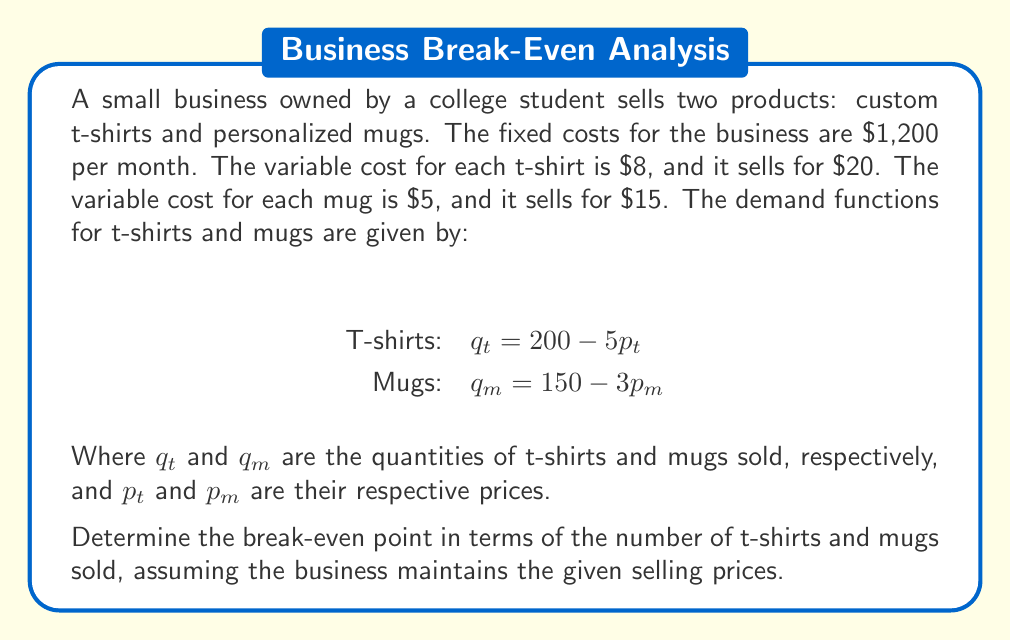Can you solve this math problem? Let's approach this step-by-step:

1) First, we need to express the quantities in terms of the given prices:
   T-shirts: $q_t = 200 - 5(20) = 100$
   Mugs: $q_m = 150 - 3(15) = 105$

2) Now, let's define our variables:
   Let x be the number of t-shirts sold
   Let y be the number of mugs sold

3) We can now set up our break-even equation:
   Revenue = Total Costs
   $20x + 15y = 1200 + 8x + 5y$

4) Simplify the equation:
   $12x + 10y = 1200$

5) We need a second equation to solve this system. We can use the ratio of the maximum quantities sold:
   $\frac{x}{y} = \frac{100}{105}$

6) Simplify this ratio:
   $21x = 20y$

7) Now we have a system of two equations:
   $12x + 10y = 1200$
   $21x - 20y = 0$

8) Multiply the second equation by 10:
   $12x + 10y = 1200$
   $210x - 200y = 0$

9) Add these equations:
   $222x - 190y = 1200$

10) Substitute $y = \frac{21x}{20}$ from step 6 into this equation:
    $222x - 190(\frac{21x}{20}) = 1200$

11) Simplify:
    $222x - 199.5x = 1200$
    $22.5x = 1200$
    $x = 53.33$

12) Substitute this value of x back into the equation from step 6:
    $y = \frac{21(53.33)}{20} = 56$

13) Round to the nearest whole number, as we can't sell partial products:
    x = 53 t-shirts
    y = 56 mugs
Answer: 53 t-shirts and 56 mugs 